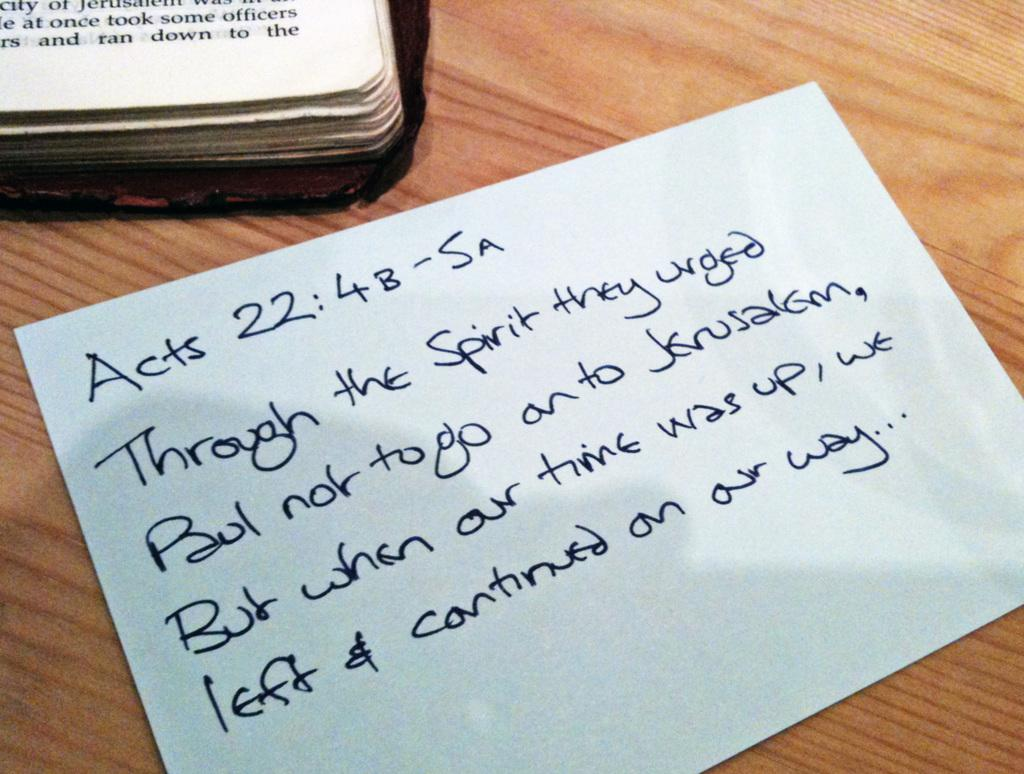<image>
Share a concise interpretation of the image provided. the word acts that is on a table 